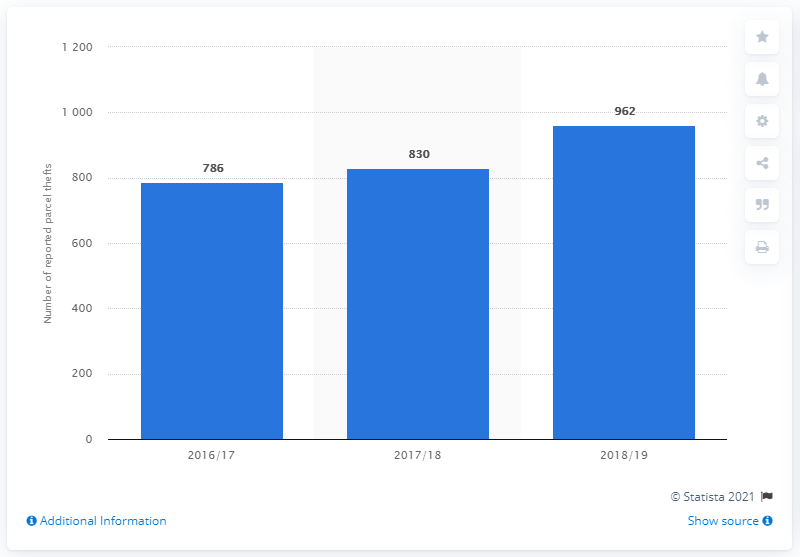Specify some key components in this picture. In the year 2018/19, a total of 962 cases of parcel theft were reported to the police. 